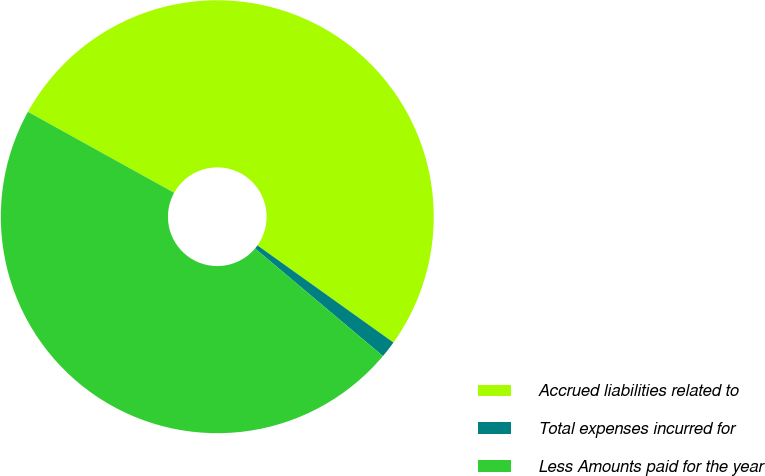Convert chart to OTSL. <chart><loc_0><loc_0><loc_500><loc_500><pie_chart><fcel>Accrued liabilities related to<fcel>Total expenses incurred for<fcel>Less Amounts paid for the year<nl><fcel>51.82%<fcel>1.26%<fcel>46.92%<nl></chart> 